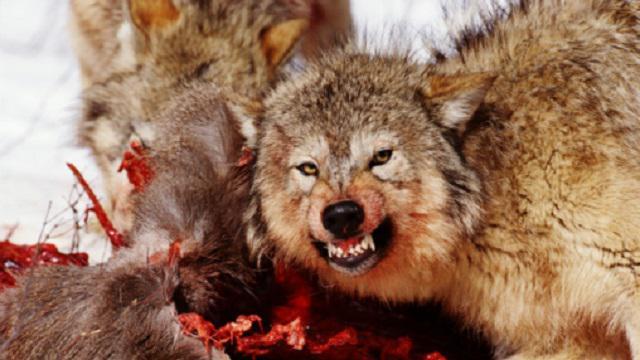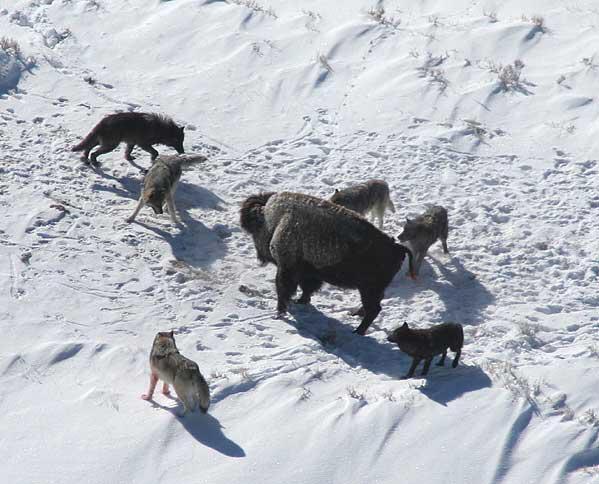The first image is the image on the left, the second image is the image on the right. For the images shown, is this caption "There is no more than one wolf in the right image." true? Answer yes or no. No. The first image is the image on the left, the second image is the image on the right. Examine the images to the left and right. Is the description "In the image on the left, a wolf bares its teeth, while looking towards the camera person." accurate? Answer yes or no. Yes. 